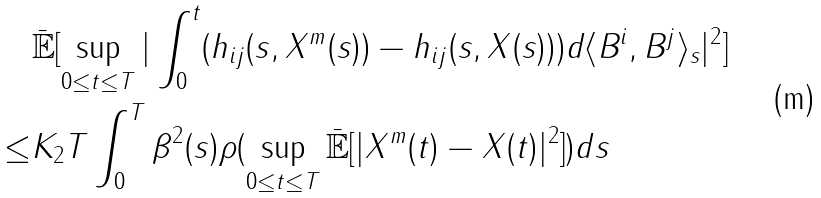<formula> <loc_0><loc_0><loc_500><loc_500>& \bar { \mathbb { E } } [ \sup _ { 0 \leq t \leq T } | \int _ { 0 } ^ { t } ( h _ { i j } ( s , X ^ { m } ( s ) ) - h _ { i j } ( s , X ( s ) ) ) d \langle B ^ { i } , B ^ { j } \rangle _ { s } | ^ { 2 } ] \\ \leq & K _ { 2 } T \int _ { 0 } ^ { T } \beta ^ { 2 } ( s ) \rho ( \sup _ { 0 \leq t \leq T } \bar { \mathbb { E } } [ | X ^ { m } ( t ) - X ( t ) | ^ { 2 } ] ) d s</formula> 